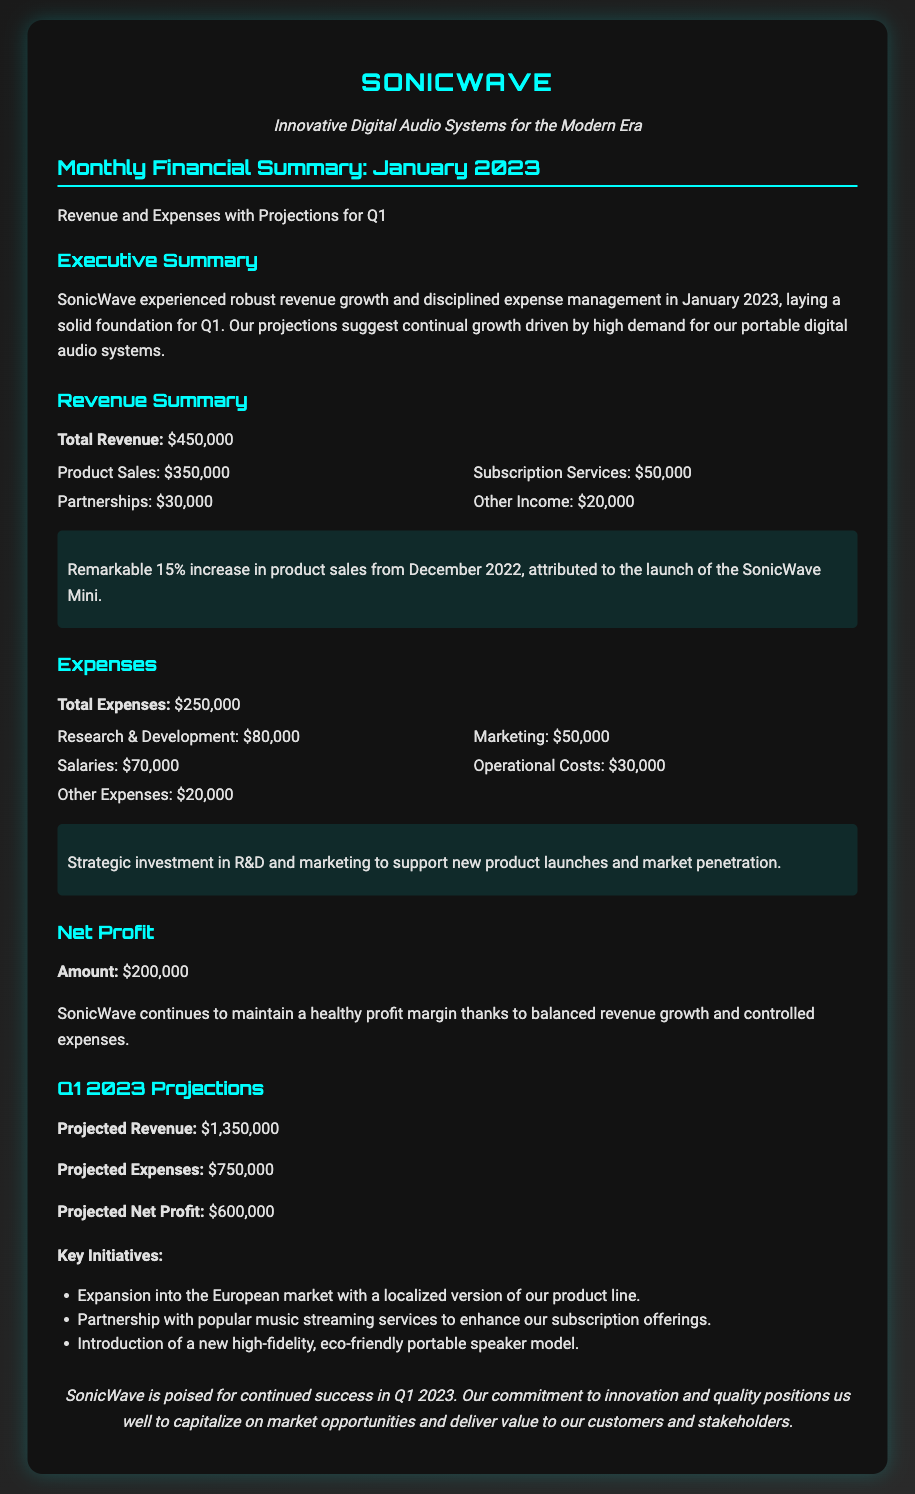What is the total revenue for January 2023? The total revenue is $450,000 as stated in the Revenue Summary section of the document.
Answer: $450,000 What was the increase in product sales from December 2022? The document notes a 15% increase in product sales attributed to the launch of the SonicWave Mini.
Answer: 15% What is the amount allocated for Research & Development expenses? The expenses section details $80,000 allocated for Research & Development.
Answer: $80,000 What is the projected net profit for Q1 2023? The document states that the projected net profit for Q1 2023 is $600,000.
Answer: $600,000 Which key initiative involves the European market? The initiative states the expansion into the European market with a localized version of the product line.
Answer: Expansion into the European market How much did SonicWave spend on Marketing in January 2023? The expenses section indicates that SonicWave spent $50,000 on Marketing.
Answer: $50,000 What percentage of total revenue came from product sales? Product sales are $350,000 out of total revenue of $450,000, which is approximately 77.78%.
Answer: 77.78% What is the highlight noted regarding the expenses? The highlight indicates strategic investment in R&D and marketing to support new product launches and market penetration.
Answer: Strategic investment in R&D and marketing What total amount did SonicWave incur in expenses for January 2023? The total expenses incurred for January 2023 are $250,000 as listed in the Expenses section.
Answer: $250,000 